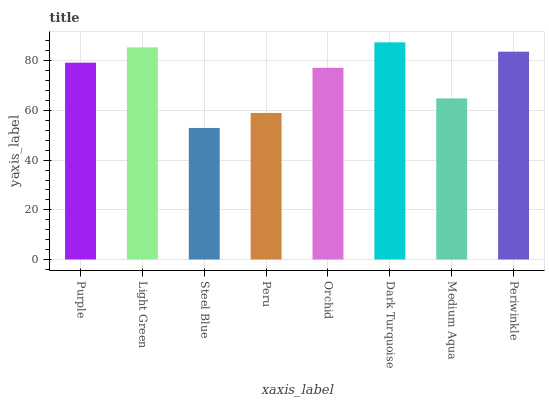Is Steel Blue the minimum?
Answer yes or no. Yes. Is Dark Turquoise the maximum?
Answer yes or no. Yes. Is Light Green the minimum?
Answer yes or no. No. Is Light Green the maximum?
Answer yes or no. No. Is Light Green greater than Purple?
Answer yes or no. Yes. Is Purple less than Light Green?
Answer yes or no. Yes. Is Purple greater than Light Green?
Answer yes or no. No. Is Light Green less than Purple?
Answer yes or no. No. Is Purple the high median?
Answer yes or no. Yes. Is Orchid the low median?
Answer yes or no. Yes. Is Periwinkle the high median?
Answer yes or no. No. Is Peru the low median?
Answer yes or no. No. 